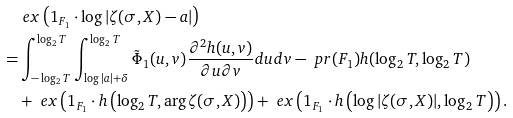<formula> <loc_0><loc_0><loc_500><loc_500>& \ e x \left ( 1 _ { F _ { 1 } } \cdot \log | \zeta ( \sigma , X ) - a | \right ) \\ = & \int _ { - \log _ { 2 } T } ^ { \log _ { 2 } T } \int _ { \log | a | + \delta } ^ { \log _ { 2 } T } \tilde { \Phi } _ { 1 } ( u , v ) \frac { \partial ^ { 2 } h ( u , v ) } { \partial u \partial v } d u d v - \ p r ( F _ { 1 } ) h ( \log _ { 2 } T , \log _ { 2 } T ) \\ & + \ e x \left ( 1 _ { F _ { 1 } } \cdot h \left ( \log _ { 2 } T , \arg \zeta ( \sigma , X ) \right ) \right ) + \ e x \left ( 1 _ { F _ { 1 } } \cdot h \left ( \log | \zeta ( \sigma , X ) | , \log _ { 2 } T \right ) \right ) . \\</formula> 